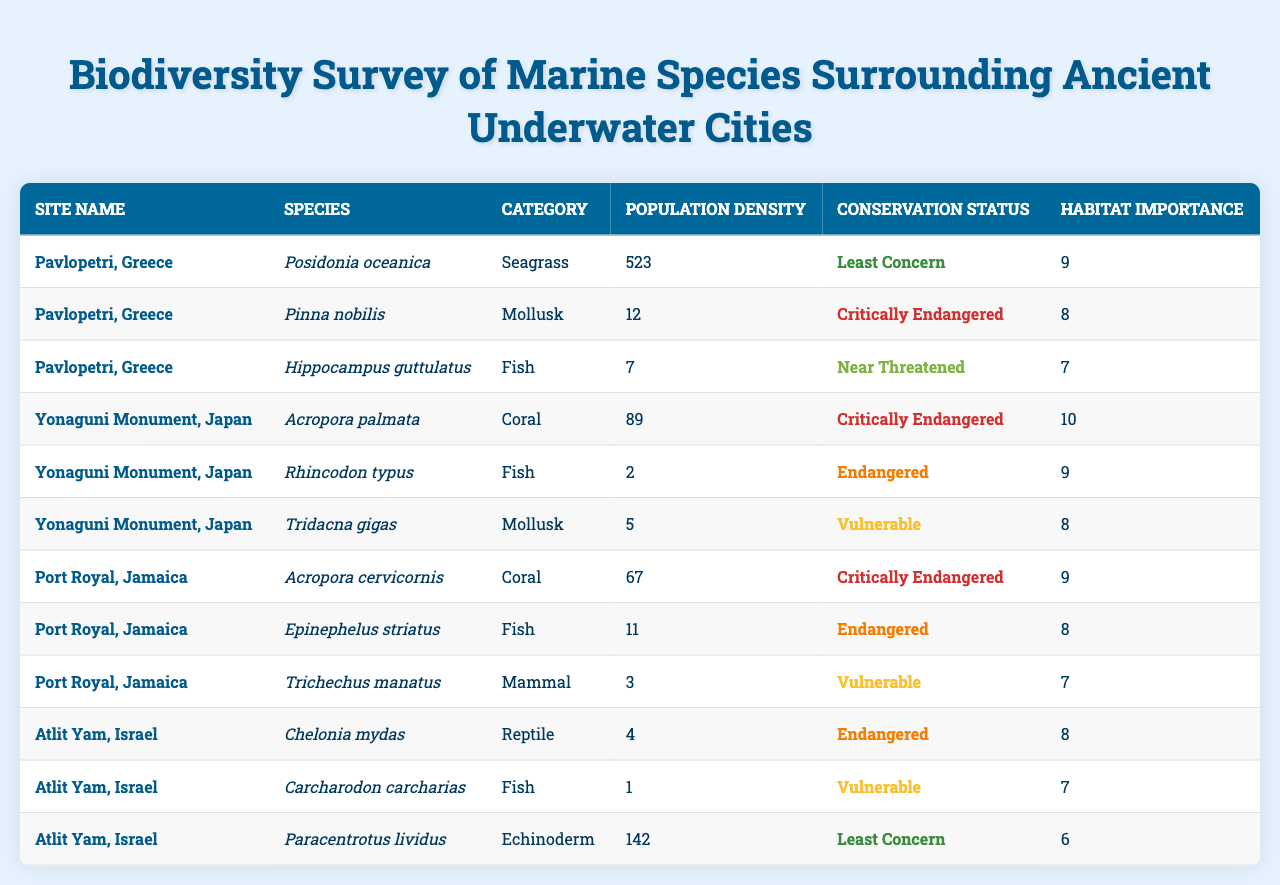What species in Pavlopetri, Greece has the highest population density? In Pavlopetri, there are three species listed: Posidonia oceanica (523), Pinna nobilis (12), and Hippocampus guttulatus (7). The highest population density is for Posidonia oceanica with 523 individuals.
Answer: Posidonia oceanica Which site has the lowest population density listed in the table? The species with the lowest population density in the table is Rhincodon typus from Yonaguni Monument, Japan, with a density of 2 individuals.
Answer: Yonaguni Monument, Japan How many species listed have a conservation status of "Critically Endangered"? There are four species in the table with a conservation status of "Critically Endangered": Pinna nobilis, Acropora palmata, Acropora cervicornis, and Tridacna gigas. Adding them gives a total of 4 species.
Answer: 4 What is the habitat importance score for species in Port Royal, Jamaica? The habitat importance scores for species in Port Royal, Jamaica are 9 for Acropora cervicornis, 8 for Epinephelus striatus, and 7 for Trichechus manatus. The average of these scores is (9 + 8 + 7) / 3 = 8.
Answer: 8 Are there any fish species with a population density greater than 10 in the entire survey? Reviewing the data for fish species: Hippocampus guttulatus (7), Rhincodon typus (2), Epinephelus striatus (11), and Carcharodon carcharias (1). Only Epinephelus striatus has a population density greater than 10.
Answer: Yes What is the total population density of all species listed for the site Atlit Yam, Israel? The population densities for Atlit Yam, Israel are Chelonia mydas (4), Carcharodon carcharias (1), and Paracentrotus lividus (142). Adding these provides a total of 4 + 1 + 142 = 147.
Answer: 147 Which category of species has the highest average population density across all sites? Calculating the average population density for each category: Seagrass (523), Mollusk (17), Fish (21), Coral (78), Mammal (3), Reptile (4), and Echinoderm (142). The highest average is for Seagrass with 523.
Answer: Seagrass Is there any species in the survey that has a habitat importance score of 10? Upon reviewing the table, the species Acropora palmata from Yonaguni Monument, Japan has a habitat importance score of 10. Therefore, there is at least one such species.
Answer: Yes Which site has the only mean density of species above 100 individuals? In the survey, only Pavlopetri, Greece shows a mean density above 100 individuals due to Posidonia oceanica (523), thus indicating it is the sole site with such density.
Answer: Pavlopetri, Greece 